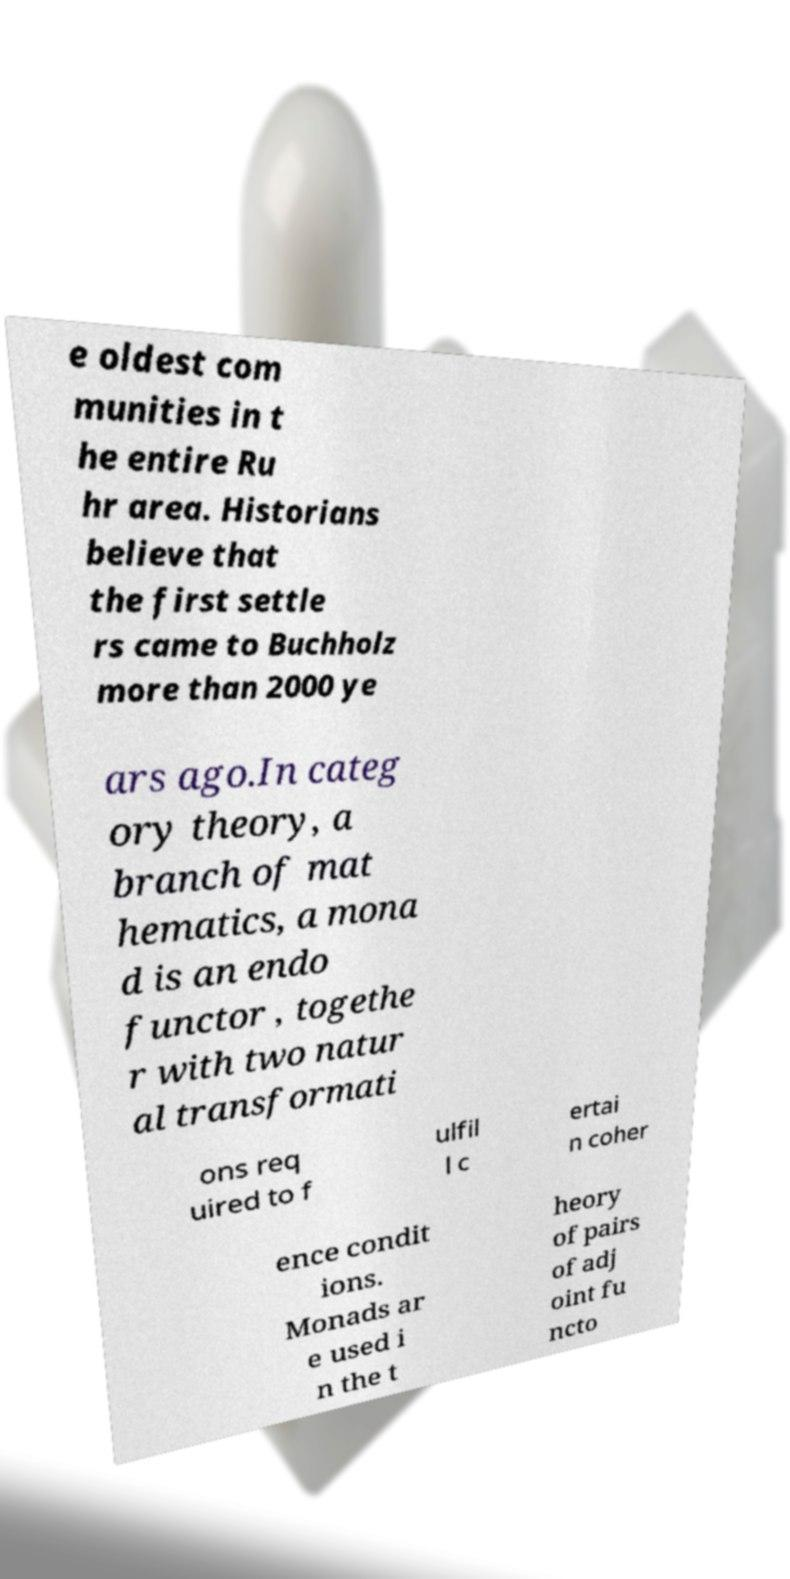Please read and relay the text visible in this image. What does it say? e oldest com munities in t he entire Ru hr area. Historians believe that the first settle rs came to Buchholz more than 2000 ye ars ago.In categ ory theory, a branch of mat hematics, a mona d is an endo functor , togethe r with two natur al transformati ons req uired to f ulfil l c ertai n coher ence condit ions. Monads ar e used i n the t heory of pairs of adj oint fu ncto 